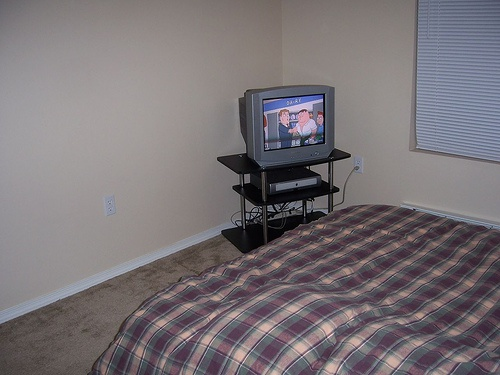Describe the objects in this image and their specific colors. I can see bed in gray, purple, darkgray, and black tones and tv in gray and black tones in this image. 